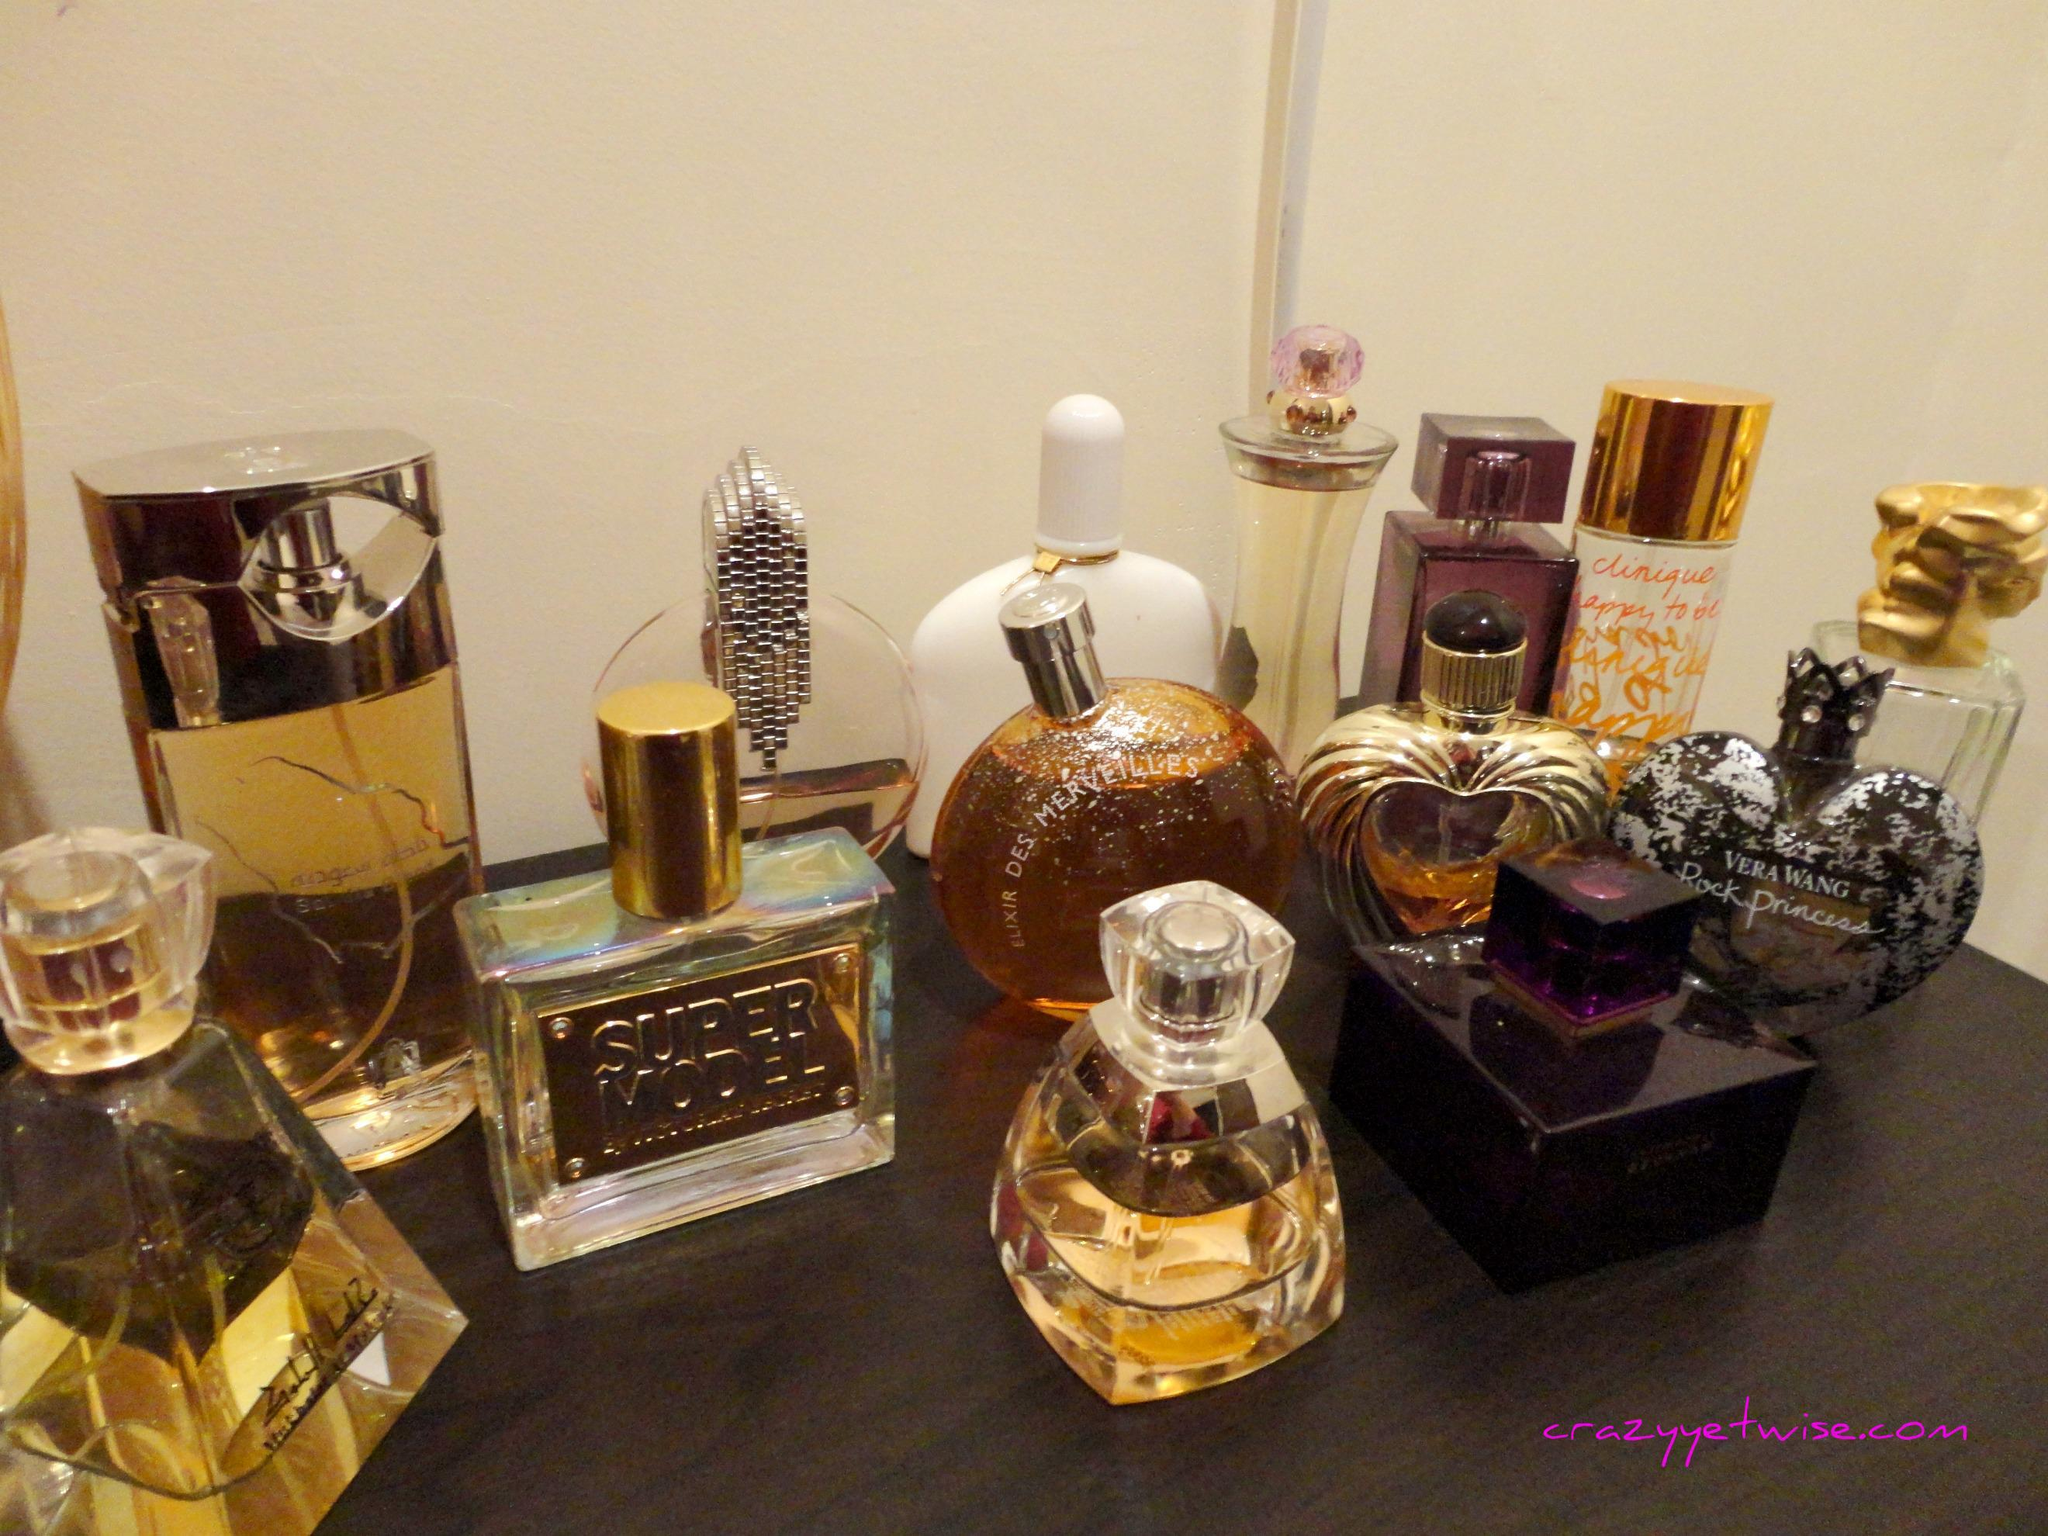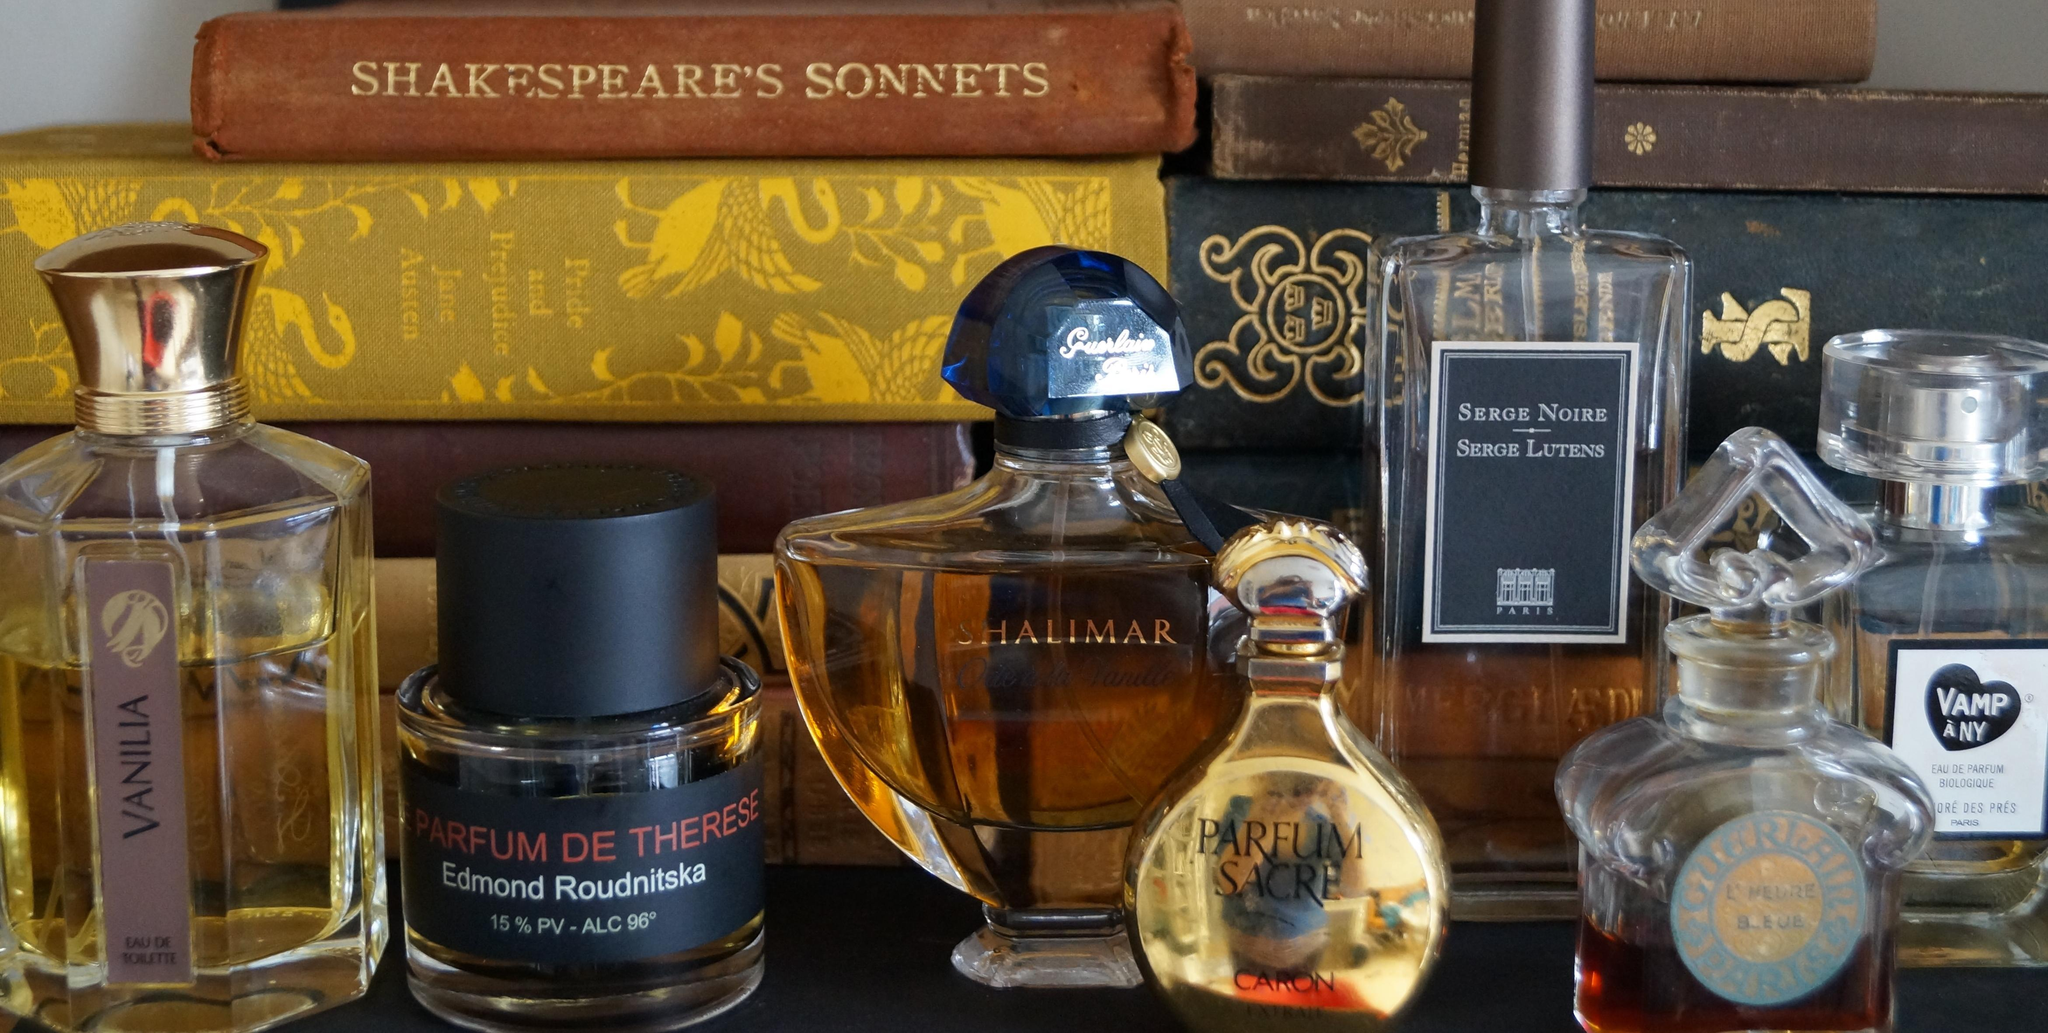The first image is the image on the left, the second image is the image on the right. For the images shown, is this caption "There are at least 10 perfume bottles with the same color and style top." true? Answer yes or no. No. The first image is the image on the left, the second image is the image on the right. Considering the images on both sides, is "Two of the perfume bottles are squat and round with rounded, reflective chrome tops." valid? Answer yes or no. No. 